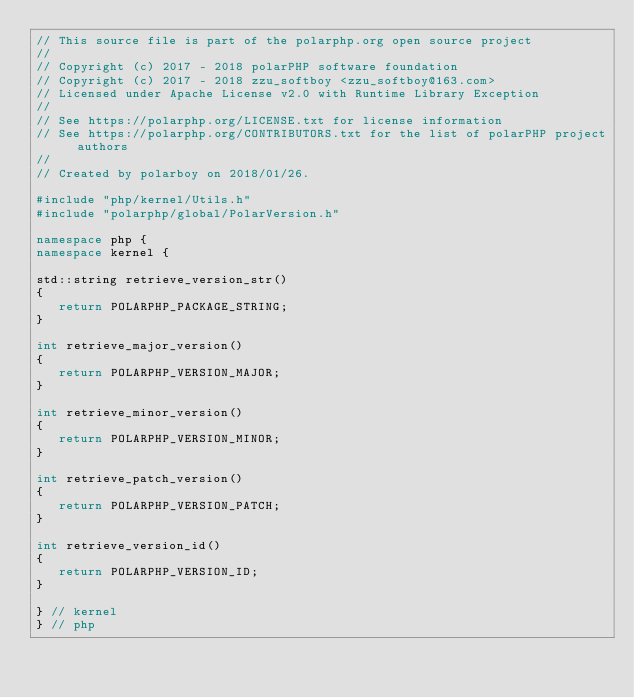Convert code to text. <code><loc_0><loc_0><loc_500><loc_500><_C++_>// This source file is part of the polarphp.org open source project
//
// Copyright (c) 2017 - 2018 polarPHP software foundation
// Copyright (c) 2017 - 2018 zzu_softboy <zzu_softboy@163.com>
// Licensed under Apache License v2.0 with Runtime Library Exception
//
// See https://polarphp.org/LICENSE.txt for license information
// See https://polarphp.org/CONTRIBUTORS.txt for the list of polarPHP project authors
//
// Created by polarboy on 2018/01/26.

#include "php/kernel/Utils.h"
#include "polarphp/global/PolarVersion.h"

namespace php {
namespace kernel {

std::string retrieve_version_str()
{
   return POLARPHP_PACKAGE_STRING;
}

int retrieve_major_version()
{
   return POLARPHP_VERSION_MAJOR;
}

int retrieve_minor_version()
{
   return POLARPHP_VERSION_MINOR;
}

int retrieve_patch_version()
{
   return POLARPHP_VERSION_PATCH;
}

int retrieve_version_id()
{
   return POLARPHP_VERSION_ID;
}

} // kernel
} // php
</code> 